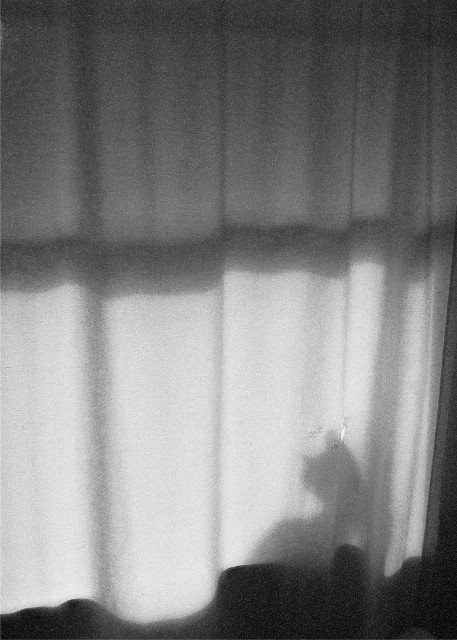Is there any significance to the lighting in this image? The lighting plays a crucial role here, as it not only creates the shadow but also enhances the texture of the curtain and highlights the ethereal quality of the scene. The direction and intensity of the light suggest a source outside the frame, contributing to a feeling of depth and mystery. What might be the source of light that creates the shadow? Given the intensity and sharpness of the shadow, the light source could be the sun shining through a window or a strong artificial light inside the room. The precise nature isn't clear, but it is certainly strong and direct to produce such a distinct silhouette. 